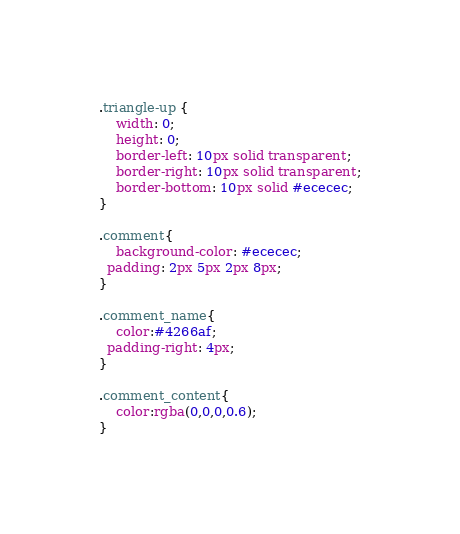<code> <loc_0><loc_0><loc_500><loc_500><_CSS_>.triangle-up {
    width: 0;
    height: 0;
    border-left: 10px solid transparent;
    border-right: 10px solid transparent;
    border-bottom: 10px solid #ececec;
}

.comment{
	background-color: #ececec;
  padding: 2px 5px 2px 8px;
}

.comment_name{
	color:#4266af;
  padding-right: 4px;
}

.comment_content{
	color:rgba(0,0,0,0.6);
}
</code> 